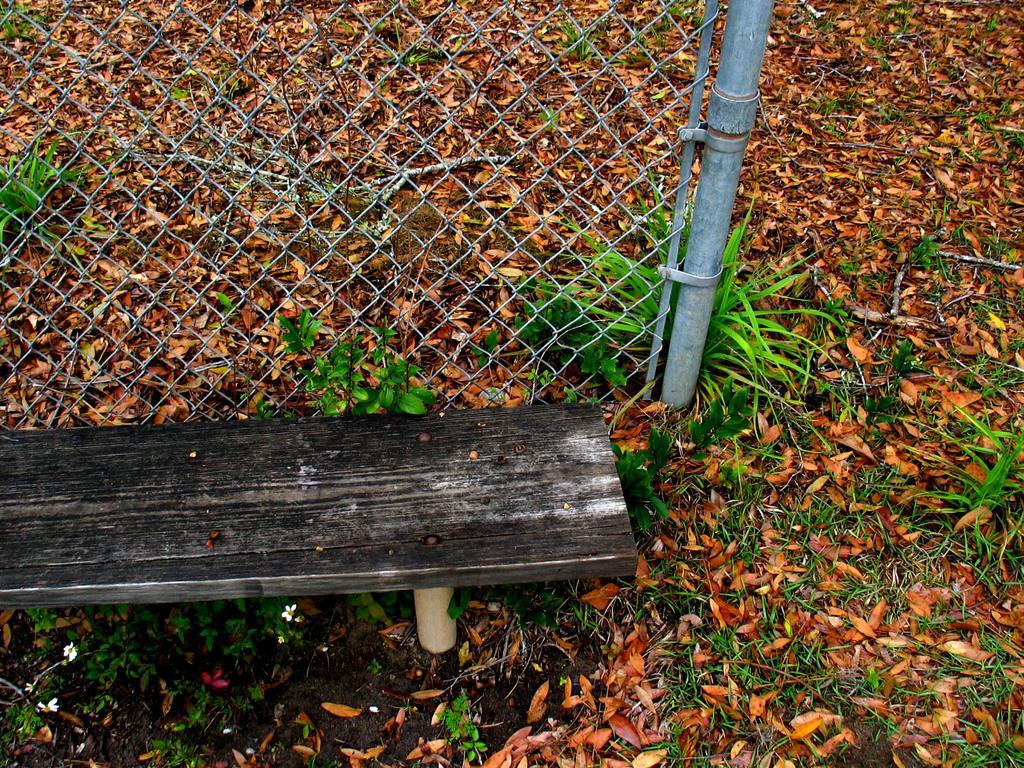Can you describe this image briefly? In this image we can see a bench, mesh, pole, dried leaves, and plants. 